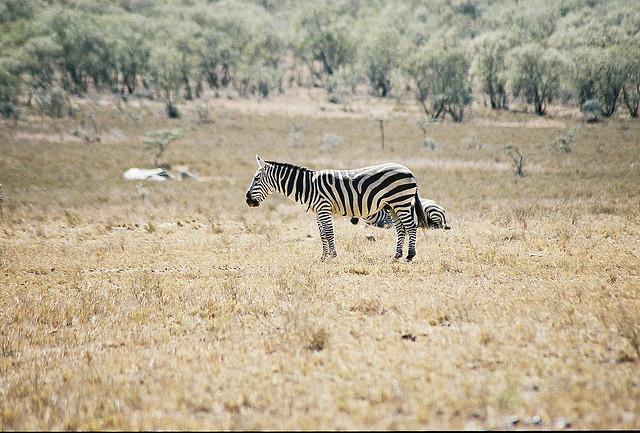Is this the zoo?
Quick response, please. No. Is the zebra in motion?
Answer briefly. No. What animal is in the foreground?
Keep it brief. Zebra. Are these animals in a zoo?
Give a very brief answer. No. How many zebra are there?
Be succinct. 2. Does this animal have stripes?
Concise answer only. Yes. Where was this probably taken?
Quick response, please. Africa. 